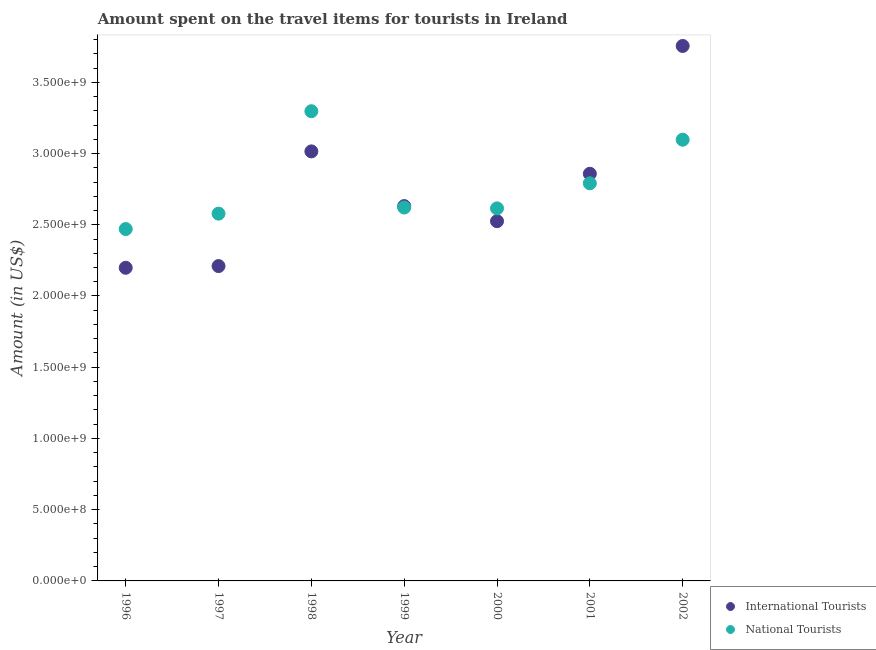Is the number of dotlines equal to the number of legend labels?
Ensure brevity in your answer.  Yes. What is the amount spent on travel items of national tourists in 1996?
Offer a very short reply. 2.47e+09. Across all years, what is the maximum amount spent on travel items of international tourists?
Give a very brief answer. 3.76e+09. Across all years, what is the minimum amount spent on travel items of national tourists?
Your answer should be very brief. 2.47e+09. In which year was the amount spent on travel items of international tourists maximum?
Provide a succinct answer. 2002. What is the total amount spent on travel items of international tourists in the graph?
Offer a very short reply. 1.92e+1. What is the difference between the amount spent on travel items of international tourists in 2000 and that in 2001?
Offer a very short reply. -3.33e+08. What is the difference between the amount spent on travel items of national tourists in 2001 and the amount spent on travel items of international tourists in 1999?
Your response must be concise. 1.60e+08. What is the average amount spent on travel items of national tourists per year?
Provide a succinct answer. 2.78e+09. In the year 2000, what is the difference between the amount spent on travel items of national tourists and amount spent on travel items of international tourists?
Provide a short and direct response. 9.00e+07. In how many years, is the amount spent on travel items of international tourists greater than 2500000000 US$?
Your answer should be compact. 5. What is the ratio of the amount spent on travel items of national tourists in 2000 to that in 2002?
Keep it short and to the point. 0.84. What is the difference between the highest and the lowest amount spent on travel items of international tourists?
Your response must be concise. 1.56e+09. In how many years, is the amount spent on travel items of national tourists greater than the average amount spent on travel items of national tourists taken over all years?
Make the answer very short. 3. Is the sum of the amount spent on travel items of international tourists in 1996 and 2001 greater than the maximum amount spent on travel items of national tourists across all years?
Make the answer very short. Yes. Does the amount spent on travel items of national tourists monotonically increase over the years?
Provide a succinct answer. No. Is the amount spent on travel items of national tourists strictly greater than the amount spent on travel items of international tourists over the years?
Provide a succinct answer. No. How many years are there in the graph?
Keep it short and to the point. 7. What is the difference between two consecutive major ticks on the Y-axis?
Your response must be concise. 5.00e+08. Does the graph contain grids?
Offer a very short reply. No. What is the title of the graph?
Keep it short and to the point. Amount spent on the travel items for tourists in Ireland. What is the label or title of the X-axis?
Your answer should be compact. Year. What is the Amount (in US$) in International Tourists in 1996?
Your response must be concise. 2.20e+09. What is the Amount (in US$) of National Tourists in 1996?
Provide a short and direct response. 2.47e+09. What is the Amount (in US$) in International Tourists in 1997?
Provide a succinct answer. 2.21e+09. What is the Amount (in US$) in National Tourists in 1997?
Keep it short and to the point. 2.58e+09. What is the Amount (in US$) in International Tourists in 1998?
Offer a very short reply. 3.02e+09. What is the Amount (in US$) of National Tourists in 1998?
Make the answer very short. 3.30e+09. What is the Amount (in US$) of International Tourists in 1999?
Your answer should be compact. 2.63e+09. What is the Amount (in US$) in National Tourists in 1999?
Make the answer very short. 2.62e+09. What is the Amount (in US$) in International Tourists in 2000?
Ensure brevity in your answer.  2.52e+09. What is the Amount (in US$) in National Tourists in 2000?
Provide a succinct answer. 2.62e+09. What is the Amount (in US$) in International Tourists in 2001?
Offer a very short reply. 2.86e+09. What is the Amount (in US$) in National Tourists in 2001?
Provide a short and direct response. 2.79e+09. What is the Amount (in US$) of International Tourists in 2002?
Your answer should be compact. 3.76e+09. What is the Amount (in US$) in National Tourists in 2002?
Keep it short and to the point. 3.10e+09. Across all years, what is the maximum Amount (in US$) in International Tourists?
Offer a very short reply. 3.76e+09. Across all years, what is the maximum Amount (in US$) of National Tourists?
Your response must be concise. 3.30e+09. Across all years, what is the minimum Amount (in US$) of International Tourists?
Your answer should be very brief. 2.20e+09. Across all years, what is the minimum Amount (in US$) of National Tourists?
Offer a very short reply. 2.47e+09. What is the total Amount (in US$) in International Tourists in the graph?
Provide a succinct answer. 1.92e+1. What is the total Amount (in US$) in National Tourists in the graph?
Provide a succinct answer. 1.95e+1. What is the difference between the Amount (in US$) in International Tourists in 1996 and that in 1997?
Your answer should be very brief. -1.20e+07. What is the difference between the Amount (in US$) in National Tourists in 1996 and that in 1997?
Give a very brief answer. -1.08e+08. What is the difference between the Amount (in US$) of International Tourists in 1996 and that in 1998?
Make the answer very short. -8.17e+08. What is the difference between the Amount (in US$) of National Tourists in 1996 and that in 1998?
Provide a succinct answer. -8.27e+08. What is the difference between the Amount (in US$) in International Tourists in 1996 and that in 1999?
Your answer should be compact. -4.33e+08. What is the difference between the Amount (in US$) in National Tourists in 1996 and that in 1999?
Your answer should be very brief. -1.51e+08. What is the difference between the Amount (in US$) of International Tourists in 1996 and that in 2000?
Your answer should be very brief. -3.27e+08. What is the difference between the Amount (in US$) in National Tourists in 1996 and that in 2000?
Provide a short and direct response. -1.45e+08. What is the difference between the Amount (in US$) in International Tourists in 1996 and that in 2001?
Offer a very short reply. -6.60e+08. What is the difference between the Amount (in US$) of National Tourists in 1996 and that in 2001?
Your response must be concise. -3.21e+08. What is the difference between the Amount (in US$) of International Tourists in 1996 and that in 2002?
Your answer should be compact. -1.56e+09. What is the difference between the Amount (in US$) in National Tourists in 1996 and that in 2002?
Keep it short and to the point. -6.27e+08. What is the difference between the Amount (in US$) in International Tourists in 1997 and that in 1998?
Keep it short and to the point. -8.05e+08. What is the difference between the Amount (in US$) of National Tourists in 1997 and that in 1998?
Offer a very short reply. -7.19e+08. What is the difference between the Amount (in US$) of International Tourists in 1997 and that in 1999?
Offer a very short reply. -4.21e+08. What is the difference between the Amount (in US$) in National Tourists in 1997 and that in 1999?
Provide a short and direct response. -4.30e+07. What is the difference between the Amount (in US$) in International Tourists in 1997 and that in 2000?
Ensure brevity in your answer.  -3.15e+08. What is the difference between the Amount (in US$) of National Tourists in 1997 and that in 2000?
Offer a very short reply. -3.70e+07. What is the difference between the Amount (in US$) in International Tourists in 1997 and that in 2001?
Provide a short and direct response. -6.48e+08. What is the difference between the Amount (in US$) in National Tourists in 1997 and that in 2001?
Provide a short and direct response. -2.13e+08. What is the difference between the Amount (in US$) of International Tourists in 1997 and that in 2002?
Offer a very short reply. -1.54e+09. What is the difference between the Amount (in US$) of National Tourists in 1997 and that in 2002?
Give a very brief answer. -5.19e+08. What is the difference between the Amount (in US$) in International Tourists in 1998 and that in 1999?
Your answer should be very brief. 3.84e+08. What is the difference between the Amount (in US$) of National Tourists in 1998 and that in 1999?
Your answer should be compact. 6.76e+08. What is the difference between the Amount (in US$) of International Tourists in 1998 and that in 2000?
Give a very brief answer. 4.90e+08. What is the difference between the Amount (in US$) of National Tourists in 1998 and that in 2000?
Give a very brief answer. 6.82e+08. What is the difference between the Amount (in US$) in International Tourists in 1998 and that in 2001?
Ensure brevity in your answer.  1.57e+08. What is the difference between the Amount (in US$) of National Tourists in 1998 and that in 2001?
Provide a succinct answer. 5.06e+08. What is the difference between the Amount (in US$) in International Tourists in 1998 and that in 2002?
Provide a succinct answer. -7.40e+08. What is the difference between the Amount (in US$) in National Tourists in 1998 and that in 2002?
Offer a terse response. 2.00e+08. What is the difference between the Amount (in US$) in International Tourists in 1999 and that in 2000?
Make the answer very short. 1.06e+08. What is the difference between the Amount (in US$) of National Tourists in 1999 and that in 2000?
Your response must be concise. 6.00e+06. What is the difference between the Amount (in US$) of International Tourists in 1999 and that in 2001?
Your answer should be compact. -2.27e+08. What is the difference between the Amount (in US$) in National Tourists in 1999 and that in 2001?
Your answer should be compact. -1.70e+08. What is the difference between the Amount (in US$) of International Tourists in 1999 and that in 2002?
Ensure brevity in your answer.  -1.12e+09. What is the difference between the Amount (in US$) in National Tourists in 1999 and that in 2002?
Keep it short and to the point. -4.76e+08. What is the difference between the Amount (in US$) of International Tourists in 2000 and that in 2001?
Provide a succinct answer. -3.33e+08. What is the difference between the Amount (in US$) of National Tourists in 2000 and that in 2001?
Your answer should be very brief. -1.76e+08. What is the difference between the Amount (in US$) of International Tourists in 2000 and that in 2002?
Ensure brevity in your answer.  -1.23e+09. What is the difference between the Amount (in US$) of National Tourists in 2000 and that in 2002?
Offer a very short reply. -4.82e+08. What is the difference between the Amount (in US$) in International Tourists in 2001 and that in 2002?
Your answer should be very brief. -8.97e+08. What is the difference between the Amount (in US$) in National Tourists in 2001 and that in 2002?
Your answer should be very brief. -3.06e+08. What is the difference between the Amount (in US$) in International Tourists in 1996 and the Amount (in US$) in National Tourists in 1997?
Ensure brevity in your answer.  -3.80e+08. What is the difference between the Amount (in US$) of International Tourists in 1996 and the Amount (in US$) of National Tourists in 1998?
Ensure brevity in your answer.  -1.10e+09. What is the difference between the Amount (in US$) in International Tourists in 1996 and the Amount (in US$) in National Tourists in 1999?
Provide a succinct answer. -4.23e+08. What is the difference between the Amount (in US$) of International Tourists in 1996 and the Amount (in US$) of National Tourists in 2000?
Offer a terse response. -4.17e+08. What is the difference between the Amount (in US$) in International Tourists in 1996 and the Amount (in US$) in National Tourists in 2001?
Make the answer very short. -5.93e+08. What is the difference between the Amount (in US$) in International Tourists in 1996 and the Amount (in US$) in National Tourists in 2002?
Your response must be concise. -8.99e+08. What is the difference between the Amount (in US$) of International Tourists in 1997 and the Amount (in US$) of National Tourists in 1998?
Keep it short and to the point. -1.09e+09. What is the difference between the Amount (in US$) in International Tourists in 1997 and the Amount (in US$) in National Tourists in 1999?
Your answer should be compact. -4.11e+08. What is the difference between the Amount (in US$) of International Tourists in 1997 and the Amount (in US$) of National Tourists in 2000?
Give a very brief answer. -4.05e+08. What is the difference between the Amount (in US$) of International Tourists in 1997 and the Amount (in US$) of National Tourists in 2001?
Give a very brief answer. -5.81e+08. What is the difference between the Amount (in US$) of International Tourists in 1997 and the Amount (in US$) of National Tourists in 2002?
Your answer should be compact. -8.87e+08. What is the difference between the Amount (in US$) of International Tourists in 1998 and the Amount (in US$) of National Tourists in 1999?
Give a very brief answer. 3.94e+08. What is the difference between the Amount (in US$) in International Tourists in 1998 and the Amount (in US$) in National Tourists in 2000?
Your response must be concise. 4.00e+08. What is the difference between the Amount (in US$) of International Tourists in 1998 and the Amount (in US$) of National Tourists in 2001?
Your answer should be very brief. 2.24e+08. What is the difference between the Amount (in US$) of International Tourists in 1998 and the Amount (in US$) of National Tourists in 2002?
Give a very brief answer. -8.20e+07. What is the difference between the Amount (in US$) in International Tourists in 1999 and the Amount (in US$) in National Tourists in 2000?
Offer a very short reply. 1.60e+07. What is the difference between the Amount (in US$) in International Tourists in 1999 and the Amount (in US$) in National Tourists in 2001?
Offer a very short reply. -1.60e+08. What is the difference between the Amount (in US$) of International Tourists in 1999 and the Amount (in US$) of National Tourists in 2002?
Your answer should be compact. -4.66e+08. What is the difference between the Amount (in US$) of International Tourists in 2000 and the Amount (in US$) of National Tourists in 2001?
Make the answer very short. -2.66e+08. What is the difference between the Amount (in US$) of International Tourists in 2000 and the Amount (in US$) of National Tourists in 2002?
Provide a succinct answer. -5.72e+08. What is the difference between the Amount (in US$) in International Tourists in 2001 and the Amount (in US$) in National Tourists in 2002?
Ensure brevity in your answer.  -2.39e+08. What is the average Amount (in US$) in International Tourists per year?
Your answer should be very brief. 2.74e+09. What is the average Amount (in US$) in National Tourists per year?
Your answer should be compact. 2.78e+09. In the year 1996, what is the difference between the Amount (in US$) of International Tourists and Amount (in US$) of National Tourists?
Your answer should be compact. -2.72e+08. In the year 1997, what is the difference between the Amount (in US$) in International Tourists and Amount (in US$) in National Tourists?
Offer a terse response. -3.68e+08. In the year 1998, what is the difference between the Amount (in US$) in International Tourists and Amount (in US$) in National Tourists?
Provide a short and direct response. -2.82e+08. In the year 2000, what is the difference between the Amount (in US$) in International Tourists and Amount (in US$) in National Tourists?
Offer a very short reply. -9.00e+07. In the year 2001, what is the difference between the Amount (in US$) of International Tourists and Amount (in US$) of National Tourists?
Provide a succinct answer. 6.70e+07. In the year 2002, what is the difference between the Amount (in US$) of International Tourists and Amount (in US$) of National Tourists?
Make the answer very short. 6.58e+08. What is the ratio of the Amount (in US$) in International Tourists in 1996 to that in 1997?
Your response must be concise. 0.99. What is the ratio of the Amount (in US$) of National Tourists in 1996 to that in 1997?
Provide a succinct answer. 0.96. What is the ratio of the Amount (in US$) of International Tourists in 1996 to that in 1998?
Give a very brief answer. 0.73. What is the ratio of the Amount (in US$) in National Tourists in 1996 to that in 1998?
Ensure brevity in your answer.  0.75. What is the ratio of the Amount (in US$) in International Tourists in 1996 to that in 1999?
Your answer should be compact. 0.84. What is the ratio of the Amount (in US$) of National Tourists in 1996 to that in 1999?
Your answer should be very brief. 0.94. What is the ratio of the Amount (in US$) in International Tourists in 1996 to that in 2000?
Offer a terse response. 0.87. What is the ratio of the Amount (in US$) in National Tourists in 1996 to that in 2000?
Ensure brevity in your answer.  0.94. What is the ratio of the Amount (in US$) of International Tourists in 1996 to that in 2001?
Make the answer very short. 0.77. What is the ratio of the Amount (in US$) of National Tourists in 1996 to that in 2001?
Ensure brevity in your answer.  0.89. What is the ratio of the Amount (in US$) in International Tourists in 1996 to that in 2002?
Give a very brief answer. 0.59. What is the ratio of the Amount (in US$) of National Tourists in 1996 to that in 2002?
Provide a succinct answer. 0.8. What is the ratio of the Amount (in US$) of International Tourists in 1997 to that in 1998?
Offer a very short reply. 0.73. What is the ratio of the Amount (in US$) in National Tourists in 1997 to that in 1998?
Your answer should be very brief. 0.78. What is the ratio of the Amount (in US$) of International Tourists in 1997 to that in 1999?
Keep it short and to the point. 0.84. What is the ratio of the Amount (in US$) in National Tourists in 1997 to that in 1999?
Make the answer very short. 0.98. What is the ratio of the Amount (in US$) of International Tourists in 1997 to that in 2000?
Give a very brief answer. 0.88. What is the ratio of the Amount (in US$) in National Tourists in 1997 to that in 2000?
Keep it short and to the point. 0.99. What is the ratio of the Amount (in US$) in International Tourists in 1997 to that in 2001?
Your response must be concise. 0.77. What is the ratio of the Amount (in US$) in National Tourists in 1997 to that in 2001?
Provide a succinct answer. 0.92. What is the ratio of the Amount (in US$) in International Tourists in 1997 to that in 2002?
Keep it short and to the point. 0.59. What is the ratio of the Amount (in US$) in National Tourists in 1997 to that in 2002?
Your response must be concise. 0.83. What is the ratio of the Amount (in US$) in International Tourists in 1998 to that in 1999?
Your answer should be very brief. 1.15. What is the ratio of the Amount (in US$) of National Tourists in 1998 to that in 1999?
Make the answer very short. 1.26. What is the ratio of the Amount (in US$) of International Tourists in 1998 to that in 2000?
Your response must be concise. 1.19. What is the ratio of the Amount (in US$) of National Tourists in 1998 to that in 2000?
Your response must be concise. 1.26. What is the ratio of the Amount (in US$) in International Tourists in 1998 to that in 2001?
Provide a short and direct response. 1.05. What is the ratio of the Amount (in US$) of National Tourists in 1998 to that in 2001?
Your response must be concise. 1.18. What is the ratio of the Amount (in US$) in International Tourists in 1998 to that in 2002?
Provide a short and direct response. 0.8. What is the ratio of the Amount (in US$) in National Tourists in 1998 to that in 2002?
Give a very brief answer. 1.06. What is the ratio of the Amount (in US$) of International Tourists in 1999 to that in 2000?
Offer a very short reply. 1.04. What is the ratio of the Amount (in US$) in International Tourists in 1999 to that in 2001?
Ensure brevity in your answer.  0.92. What is the ratio of the Amount (in US$) in National Tourists in 1999 to that in 2001?
Offer a terse response. 0.94. What is the ratio of the Amount (in US$) of International Tourists in 1999 to that in 2002?
Offer a very short reply. 0.7. What is the ratio of the Amount (in US$) in National Tourists in 1999 to that in 2002?
Offer a terse response. 0.85. What is the ratio of the Amount (in US$) in International Tourists in 2000 to that in 2001?
Offer a terse response. 0.88. What is the ratio of the Amount (in US$) of National Tourists in 2000 to that in 2001?
Your answer should be compact. 0.94. What is the ratio of the Amount (in US$) of International Tourists in 2000 to that in 2002?
Give a very brief answer. 0.67. What is the ratio of the Amount (in US$) in National Tourists in 2000 to that in 2002?
Ensure brevity in your answer.  0.84. What is the ratio of the Amount (in US$) of International Tourists in 2001 to that in 2002?
Provide a short and direct response. 0.76. What is the ratio of the Amount (in US$) of National Tourists in 2001 to that in 2002?
Offer a very short reply. 0.9. What is the difference between the highest and the second highest Amount (in US$) in International Tourists?
Your response must be concise. 7.40e+08. What is the difference between the highest and the lowest Amount (in US$) of International Tourists?
Offer a terse response. 1.56e+09. What is the difference between the highest and the lowest Amount (in US$) of National Tourists?
Ensure brevity in your answer.  8.27e+08. 